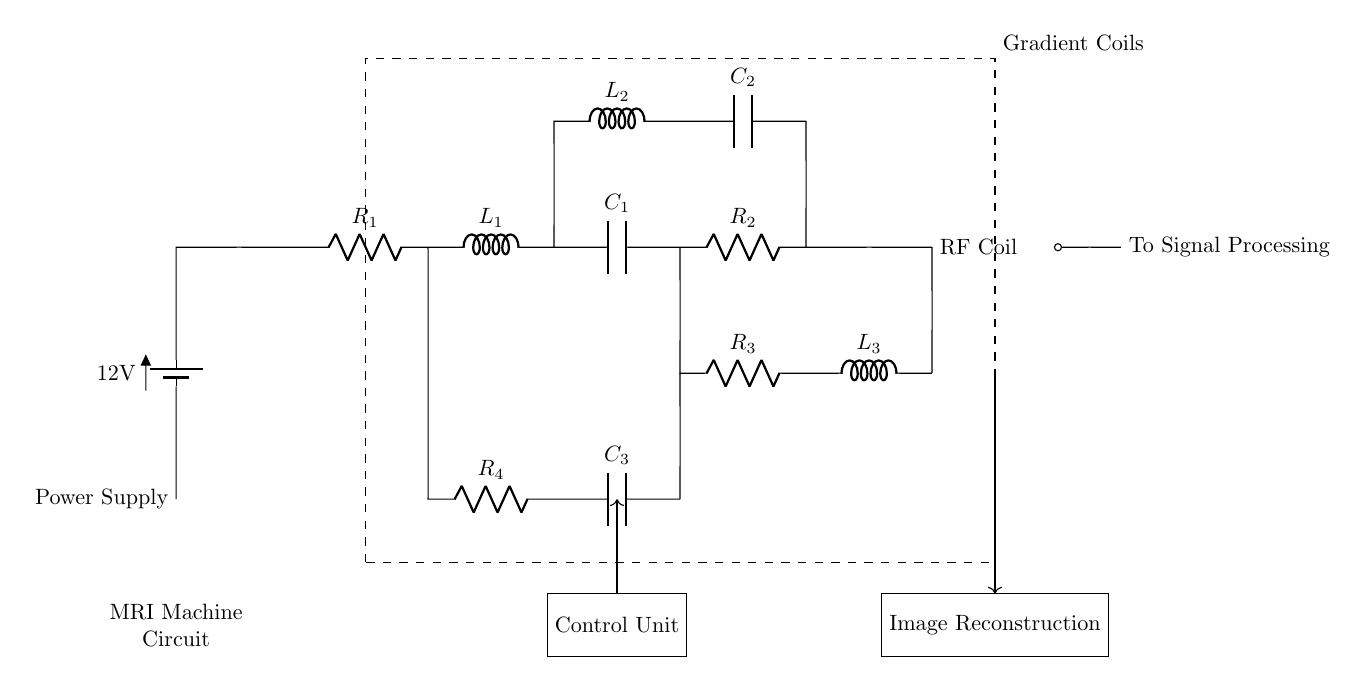What is the power supply voltage? The power supply provides a voltage of 12V, as indicated by the battery symbol in the circuit diagram.
Answer: 12V What component is represented by R1? R1 is labeled as a resistor in the circuit, used to limit current or drop voltage.
Answer: Resistor How many inductors are in this circuit? The circuit diagram contains three inductors, labeled L1, L2, and L3, which are used in various segments of the circuit.
Answer: Three What is the purpose of the RF Coil? The RF Coil generates radiofrequency signals necessary for MRI operation, facilitating image capture.
Answer: To generate RF signals Which components are part of the Gradient Coils section? The Gradient Coils section includes R1, L1, C1, R2, L2, C2, R3, and L3 as indicated within the dashed rectangle.
Answer: R1, L1, C1, R2, L2, C2, R3, L3 If C1 fails, which components are directly affected? If C1 fails, the circuit's function in generating and detecting magnetic fields is disrupted, affecting the operation of all components connected to it directly, namely R2 and L1.
Answer: R2 and L1 What is the primary function of the Control Unit? The Control Unit coordinates the operation of the MRI machine, managing signal processing and image reconstruction based on inputs.
Answer: Coordination of operations 